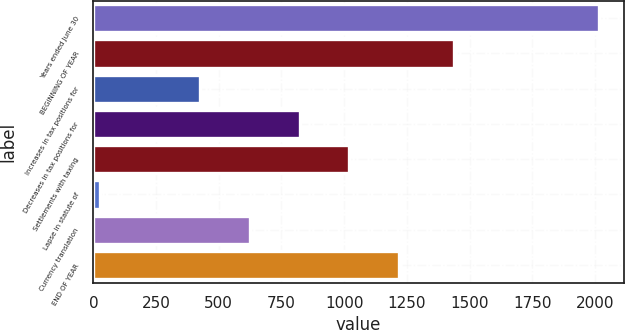Convert chart to OTSL. <chart><loc_0><loc_0><loc_500><loc_500><bar_chart><fcel>Years ended June 30<fcel>BEGINNING OF YEAR<fcel>Increases in tax positions for<fcel>Decreases in tax positions for<fcel>Settlements with taxing<fcel>Lapse in statute of<fcel>Currency translation<fcel>END OF YEAR<nl><fcel>2015<fcel>1437<fcel>424.6<fcel>822.2<fcel>1021<fcel>27<fcel>623.4<fcel>1219.8<nl></chart> 